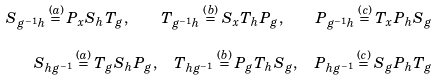Convert formula to latex. <formula><loc_0><loc_0><loc_500><loc_500>S _ { g ^ { - 1 } h } \overset { ( a ) } { = } P _ { x } S _ { h } T _ { g } , \quad T _ { g ^ { - 1 } h } \overset { ( b ) } { = } S _ { x } T _ { h } P _ { g } , \quad P _ { g ^ { - 1 } h } \overset { ( c ) } { = } T _ { x } P _ { h } S _ { g } \\ S _ { h g ^ { - 1 } } \overset { ( a ) } { = } T _ { g } S _ { h } P _ { g } , \quad T _ { h g ^ { - 1 } } \overset { ( b ) } { = } P _ { g } T _ { h } S _ { g } , \quad P _ { h g ^ { - 1 } } \overset { ( c ) } { = } S _ { g } P _ { h } T _ { g }</formula> 